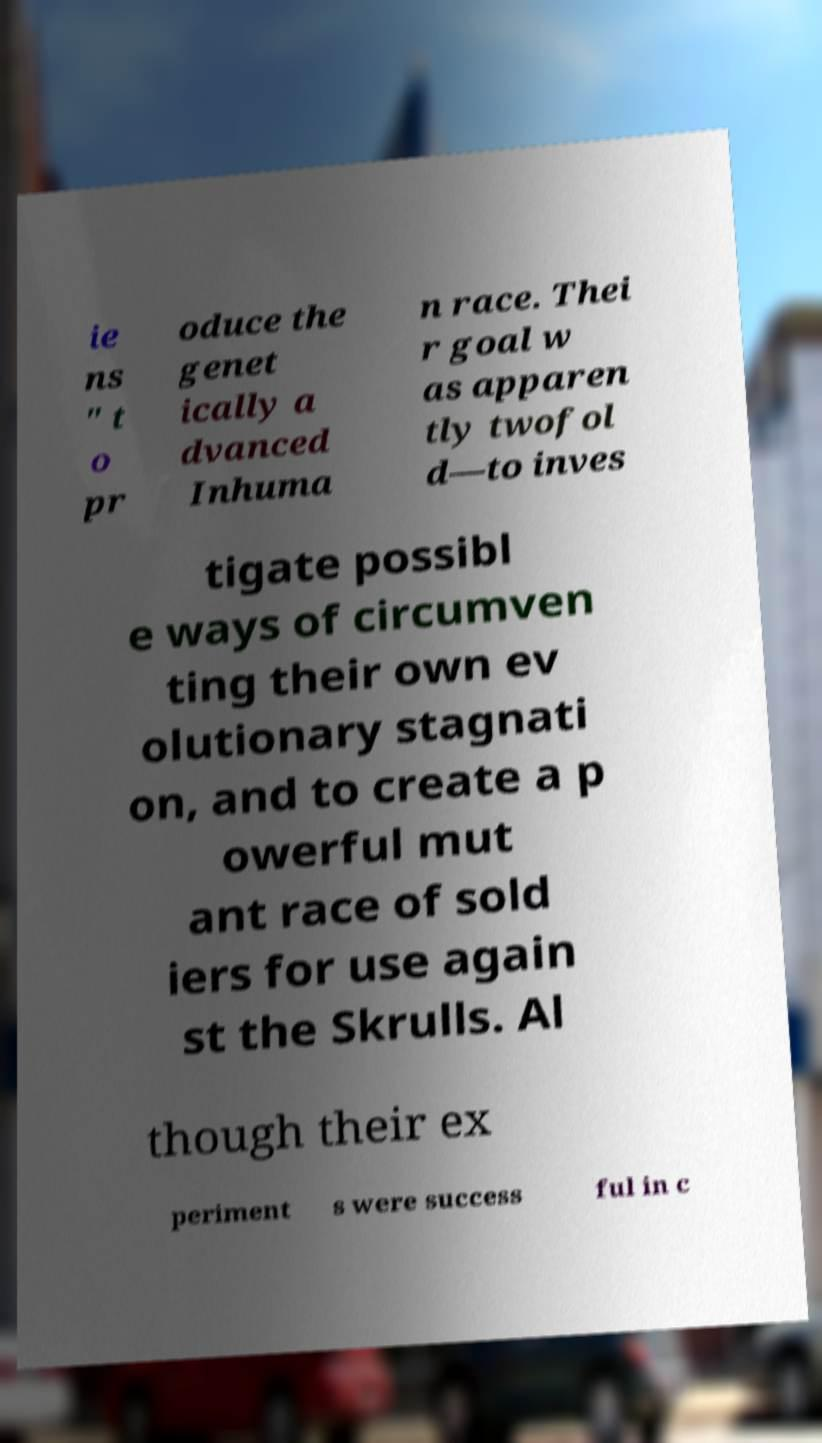Please read and relay the text visible in this image. What does it say? ie ns " t o pr oduce the genet ically a dvanced Inhuma n race. Thei r goal w as apparen tly twofol d—to inves tigate possibl e ways of circumven ting their own ev olutionary stagnati on, and to create a p owerful mut ant race of sold iers for use again st the Skrulls. Al though their ex periment s were success ful in c 